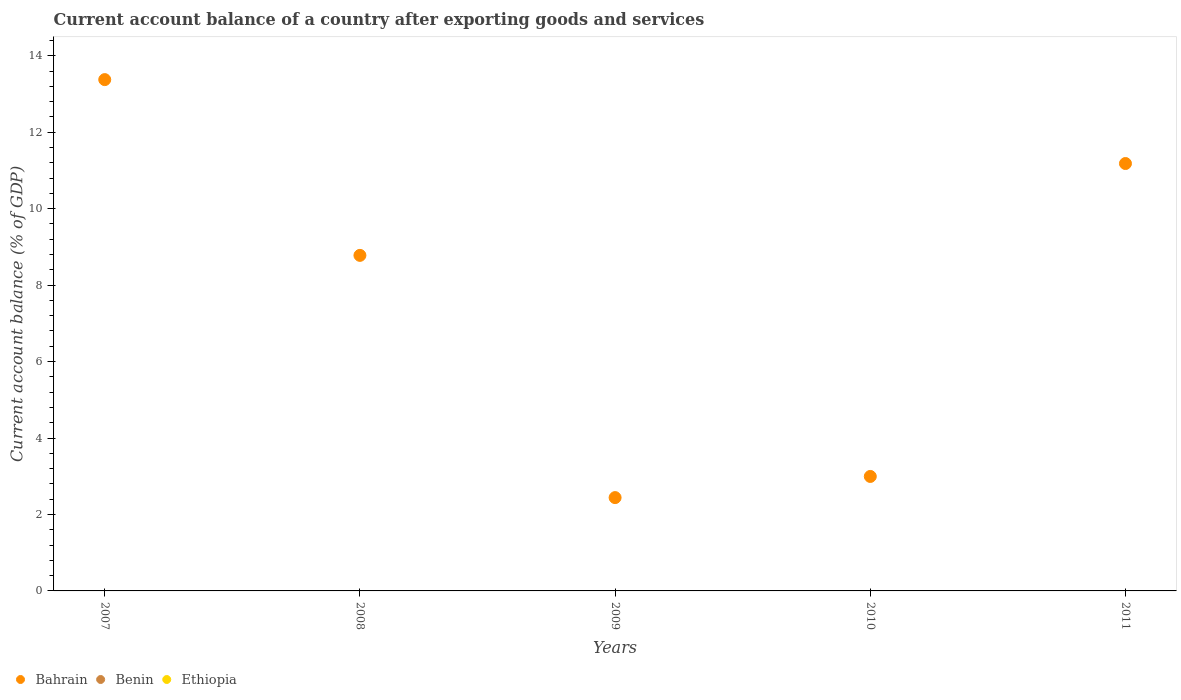How many different coloured dotlines are there?
Offer a very short reply. 1. Is the number of dotlines equal to the number of legend labels?
Provide a succinct answer. No. What is the account balance in Bahrain in 2011?
Offer a very short reply. 11.18. Across all years, what is the maximum account balance in Bahrain?
Give a very brief answer. 13.38. Across all years, what is the minimum account balance in Bahrain?
Provide a succinct answer. 2.44. What is the difference between the account balance in Bahrain in 2007 and that in 2008?
Offer a very short reply. 4.6. What is the difference between the account balance in Bahrain in 2011 and the account balance in Benin in 2008?
Provide a short and direct response. 11.18. What is the average account balance in Ethiopia per year?
Keep it short and to the point. 0. Is the account balance in Bahrain in 2007 less than that in 2011?
Keep it short and to the point. No. What is the difference between the highest and the second highest account balance in Bahrain?
Your answer should be very brief. 2.2. What is the difference between the highest and the lowest account balance in Bahrain?
Provide a short and direct response. 10.93. Is the sum of the account balance in Bahrain in 2007 and 2010 greater than the maximum account balance in Ethiopia across all years?
Keep it short and to the point. Yes. Is the account balance in Ethiopia strictly greater than the account balance in Bahrain over the years?
Your response must be concise. No. How many dotlines are there?
Offer a very short reply. 1. What is the difference between two consecutive major ticks on the Y-axis?
Your response must be concise. 2. Does the graph contain any zero values?
Keep it short and to the point. Yes. Does the graph contain grids?
Provide a succinct answer. No. How are the legend labels stacked?
Ensure brevity in your answer.  Horizontal. What is the title of the graph?
Provide a succinct answer. Current account balance of a country after exporting goods and services. Does "Seychelles" appear as one of the legend labels in the graph?
Ensure brevity in your answer.  No. What is the label or title of the Y-axis?
Offer a very short reply. Current account balance (% of GDP). What is the Current account balance (% of GDP) in Bahrain in 2007?
Your answer should be very brief. 13.38. What is the Current account balance (% of GDP) of Bahrain in 2008?
Give a very brief answer. 8.78. What is the Current account balance (% of GDP) in Ethiopia in 2008?
Provide a short and direct response. 0. What is the Current account balance (% of GDP) in Bahrain in 2009?
Ensure brevity in your answer.  2.44. What is the Current account balance (% of GDP) of Bahrain in 2010?
Your answer should be compact. 2.99. What is the Current account balance (% of GDP) of Bahrain in 2011?
Keep it short and to the point. 11.18. What is the Current account balance (% of GDP) of Ethiopia in 2011?
Keep it short and to the point. 0. Across all years, what is the maximum Current account balance (% of GDP) of Bahrain?
Offer a very short reply. 13.38. Across all years, what is the minimum Current account balance (% of GDP) of Bahrain?
Make the answer very short. 2.44. What is the total Current account balance (% of GDP) in Bahrain in the graph?
Your response must be concise. 38.77. What is the total Current account balance (% of GDP) in Benin in the graph?
Ensure brevity in your answer.  0. What is the total Current account balance (% of GDP) of Ethiopia in the graph?
Your answer should be compact. 0. What is the difference between the Current account balance (% of GDP) of Bahrain in 2007 and that in 2008?
Offer a very short reply. 4.6. What is the difference between the Current account balance (% of GDP) of Bahrain in 2007 and that in 2009?
Keep it short and to the point. 10.93. What is the difference between the Current account balance (% of GDP) of Bahrain in 2007 and that in 2010?
Offer a very short reply. 10.38. What is the difference between the Current account balance (% of GDP) in Bahrain in 2007 and that in 2011?
Provide a succinct answer. 2.2. What is the difference between the Current account balance (% of GDP) of Bahrain in 2008 and that in 2009?
Keep it short and to the point. 6.34. What is the difference between the Current account balance (% of GDP) in Bahrain in 2008 and that in 2010?
Your answer should be very brief. 5.78. What is the difference between the Current account balance (% of GDP) of Bahrain in 2008 and that in 2011?
Make the answer very short. -2.4. What is the difference between the Current account balance (% of GDP) in Bahrain in 2009 and that in 2010?
Give a very brief answer. -0.55. What is the difference between the Current account balance (% of GDP) in Bahrain in 2009 and that in 2011?
Make the answer very short. -8.74. What is the difference between the Current account balance (% of GDP) in Bahrain in 2010 and that in 2011?
Offer a terse response. -8.19. What is the average Current account balance (% of GDP) in Bahrain per year?
Provide a succinct answer. 7.75. What is the average Current account balance (% of GDP) of Benin per year?
Your response must be concise. 0. What is the average Current account balance (% of GDP) in Ethiopia per year?
Ensure brevity in your answer.  0. What is the ratio of the Current account balance (% of GDP) of Bahrain in 2007 to that in 2008?
Your answer should be compact. 1.52. What is the ratio of the Current account balance (% of GDP) in Bahrain in 2007 to that in 2009?
Your response must be concise. 5.48. What is the ratio of the Current account balance (% of GDP) in Bahrain in 2007 to that in 2010?
Offer a terse response. 4.47. What is the ratio of the Current account balance (% of GDP) of Bahrain in 2007 to that in 2011?
Provide a succinct answer. 1.2. What is the ratio of the Current account balance (% of GDP) in Bahrain in 2008 to that in 2009?
Provide a succinct answer. 3.6. What is the ratio of the Current account balance (% of GDP) of Bahrain in 2008 to that in 2010?
Your answer should be very brief. 2.93. What is the ratio of the Current account balance (% of GDP) of Bahrain in 2008 to that in 2011?
Give a very brief answer. 0.79. What is the ratio of the Current account balance (% of GDP) of Bahrain in 2009 to that in 2010?
Ensure brevity in your answer.  0.82. What is the ratio of the Current account balance (% of GDP) of Bahrain in 2009 to that in 2011?
Your answer should be very brief. 0.22. What is the ratio of the Current account balance (% of GDP) in Bahrain in 2010 to that in 2011?
Offer a very short reply. 0.27. What is the difference between the highest and the second highest Current account balance (% of GDP) of Bahrain?
Offer a very short reply. 2.2. What is the difference between the highest and the lowest Current account balance (% of GDP) of Bahrain?
Make the answer very short. 10.93. 